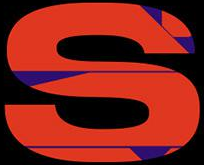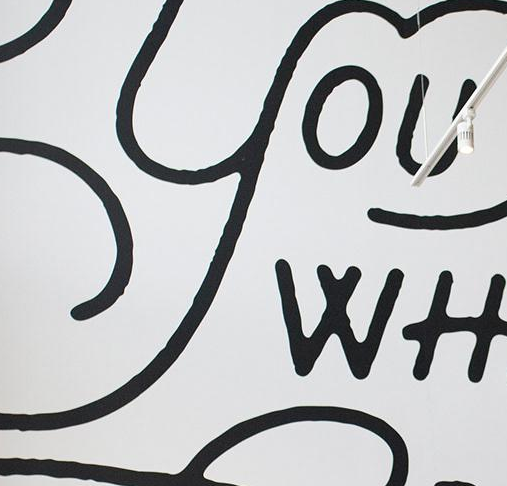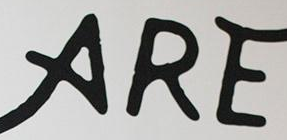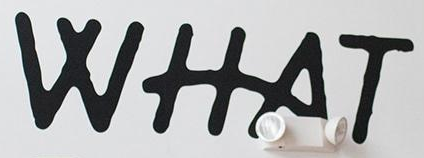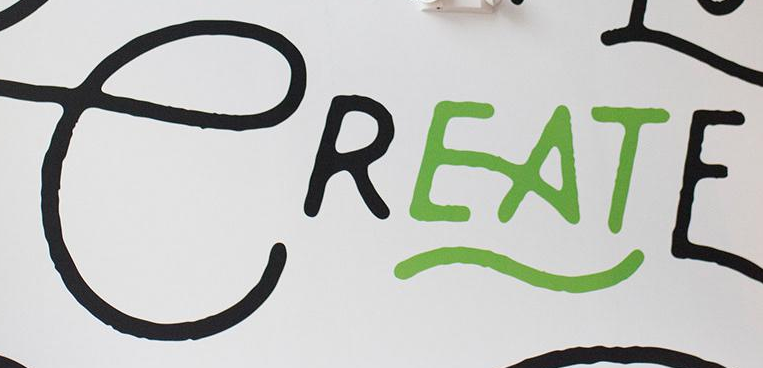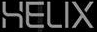Transcribe the words shown in these images in order, separated by a semicolon. S; YOU; ARE; WHAT; CREATE; HELIX 